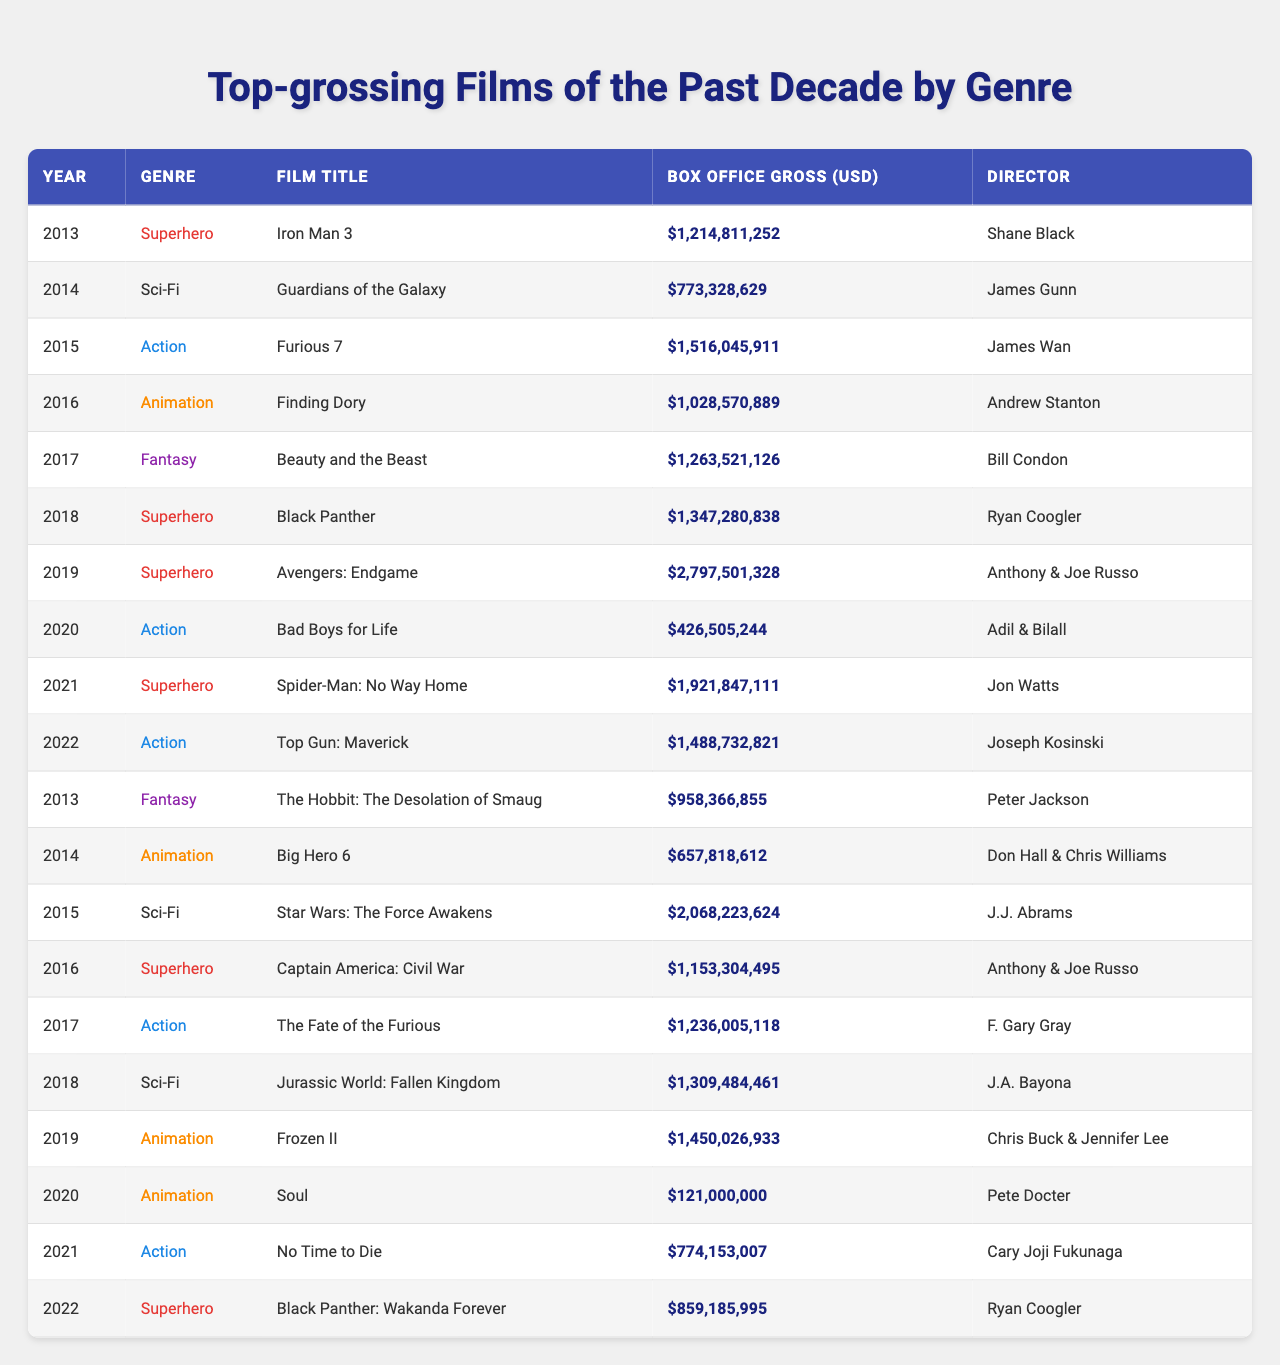What is the highest box office gross among the films listed? The highest numeric value in the "Box Office Gross (USD)" column is 2,797,501,328, which belongs to "Avengers: Endgame" released in 2019.
Answer: 2,797,501,328 Which genre has the most entries in the table? By examining the "Genre" column, "Superhero" appears 5 times, more than any other genre, indicating that it has the most entries.
Answer: Superhero What is the total box office gross of the Action films? Adding the gross values of the Action films (Furious 7: 1,516,045,911, Bad Boys for Life: 426,505,244, The Fate of the Furious: 1,236,005,118, Top Gun: Maverick: 1,488,732,821, No Time to Die: 774,153,007), we get a total of 5,441,466,101.
Answer: 5,441,466,101 How many films directed by Ryan Coogler are in the table? Upon reviewing the "Director" column, Ryan Coogler is listed as the director for 2 films, "Black Panther" (2018) and "Black Panther: Wakanda Forever" (2022).
Answer: 2 Which film has the second-highest box office gross? By identifying the films with the highest gross amounts, "Spider-Man: No Way Home" (2021) with 1,921,847,111 is the second highest following "Avengers: Endgame" (2019).
Answer: Spider-Man: No Way Home Is there any Animation film that grossed over 1 billion USD? Evaluating the box office gross for the Animation genre, "Finding Dory" (2016) grossed 1,028,570,889, meaning at least one Animation film made over 1 billion USD.
Answer: Yes What is the average box office gross across all films in the table? Summing all box office gross values (approximately 15,582,346,382) and dividing by the total number of films (20) results in an average gross of about 779,117,319.
Answer: 779,117,319 Which year saw the release of the film with the lowest box office gross? The film with the lowest box office gross is "Soul" (2020) grossing 121,000,000, which indicates it has the lowest value in that respective year.
Answer: 2020 What percentage of the films in the table are categorized as Superhero? There are 5 Superhero films out of a total of 20 films, leading to a percentage of (5/20) * 100, which equals 25%.
Answer: 25% What is the difference in box office gross between the highest and lowest grossing films? The highest grossing film is "Avengers: Endgame" (2,797,501,328) and the lowest is "Soul" (121,000,000). The difference is 2,797,501,328 - 121,000,000 = 2,676,501,328.
Answer: 2,676,501,328 How many genres are represented in the data? By reviewing the "Genre" column, there are five unique genres present: Superhero, Sci-Fi, Action, Animation, and Fantasy.
Answer: 5 